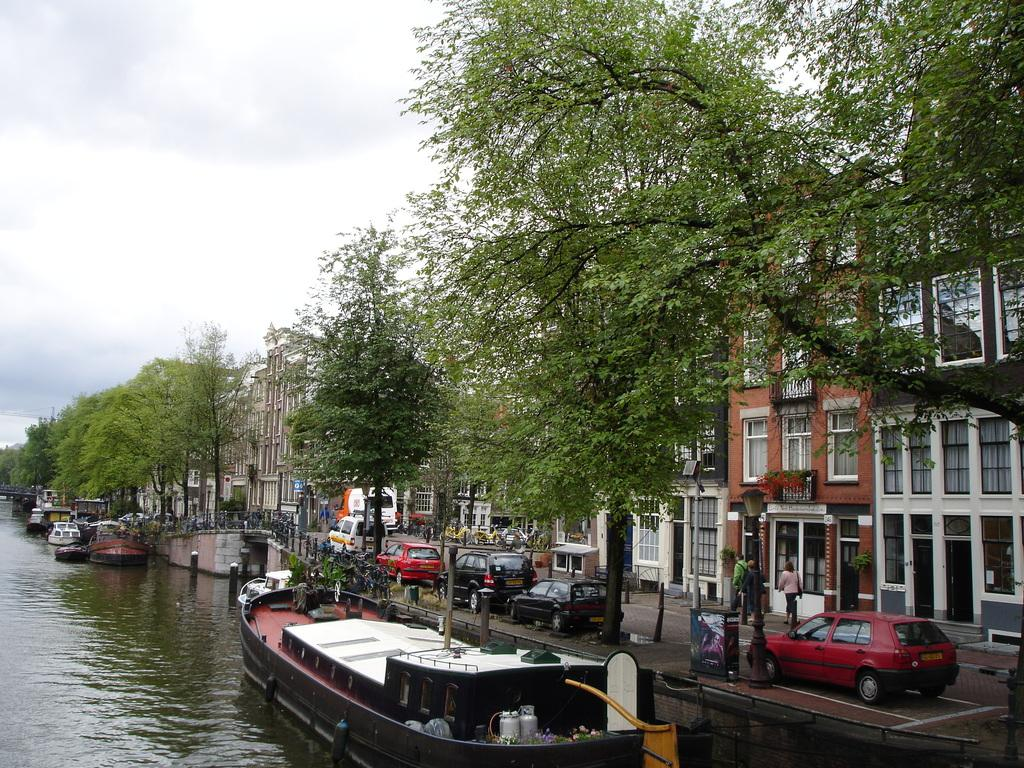What type of structures can be seen in the image? There are buildings in the image. What other natural elements are present in the image? There are trees in the image. What mode of transportation can be seen on the road in the image? There are cars on the road in the image. What is floating on the water in the image? There are boats floating on the water in the image. What is visible at the top of the image? The sky is visible at the top of the image. Can you tell me how many friends are exchanging paper in the image? There is no mention of friends exchanging paper in the image; the facts provided only discuss buildings, trees, cars, boats, and the sky. 